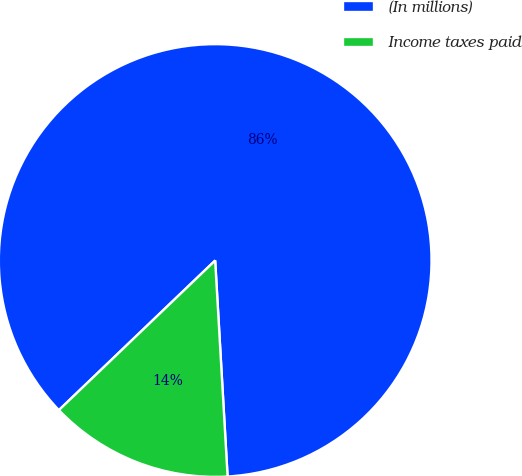Convert chart to OTSL. <chart><loc_0><loc_0><loc_500><loc_500><pie_chart><fcel>(In millions)<fcel>Income taxes paid<nl><fcel>86.24%<fcel>13.76%<nl></chart> 